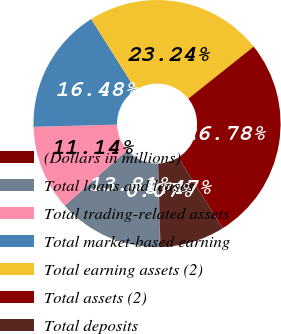<chart> <loc_0><loc_0><loc_500><loc_500><pie_chart><fcel>(Dollars in millions)<fcel>Total loans and leases<fcel>Total trading-related assets<fcel>Total market-based earning<fcel>Total earning assets (2)<fcel>Total assets (2)<fcel>Total deposits<nl><fcel>0.07%<fcel>13.81%<fcel>11.14%<fcel>16.48%<fcel>23.24%<fcel>26.78%<fcel>8.47%<nl></chart> 